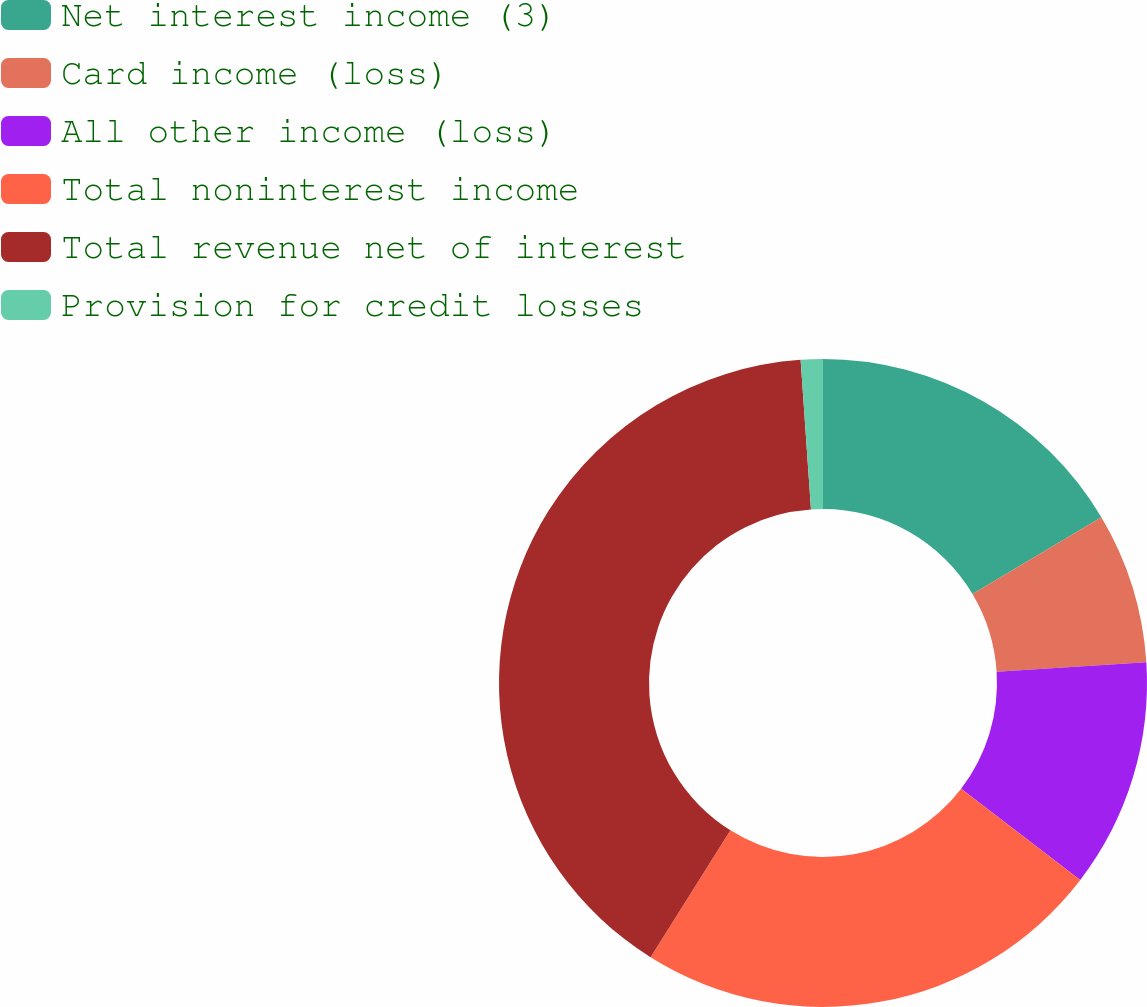Convert chart. <chart><loc_0><loc_0><loc_500><loc_500><pie_chart><fcel>Net interest income (3)<fcel>Card income (loss)<fcel>All other income (loss)<fcel>Total noninterest income<fcel>Total revenue net of interest<fcel>Provision for credit losses<nl><fcel>16.45%<fcel>7.53%<fcel>11.42%<fcel>23.53%<fcel>39.97%<fcel>1.1%<nl></chart> 